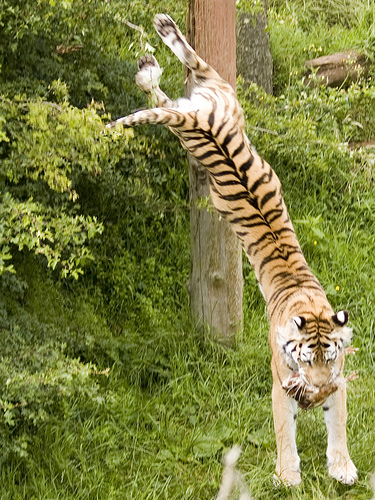<image>
Is there a tiger in front of the plant? Yes. The tiger is positioned in front of the plant, appearing closer to the camera viewpoint. 